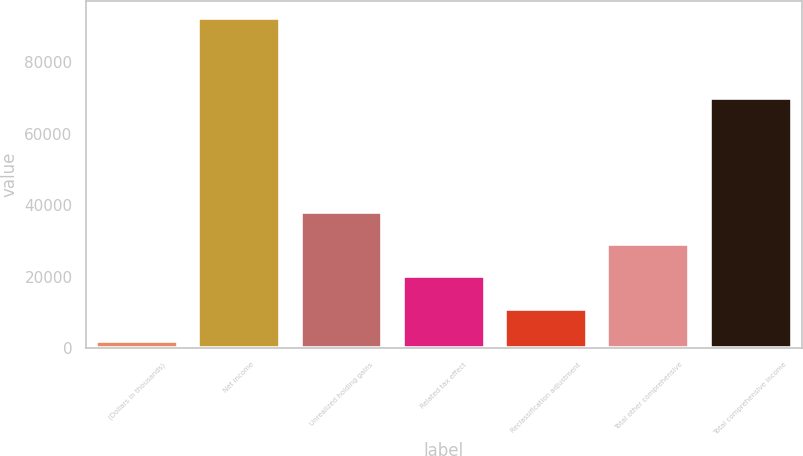Convert chart to OTSL. <chart><loc_0><loc_0><loc_500><loc_500><bar_chart><fcel>(Dollars in thousands)<fcel>Net income<fcel>Unrealized holding gains<fcel>Related tax effect<fcel>Reclassification adjustment<fcel>Total other comprehensive<fcel>Total comprehensive income<nl><fcel>2005<fcel>92537<fcel>38217.8<fcel>20111.4<fcel>11058.2<fcel>29164.6<fcel>70156<nl></chart> 